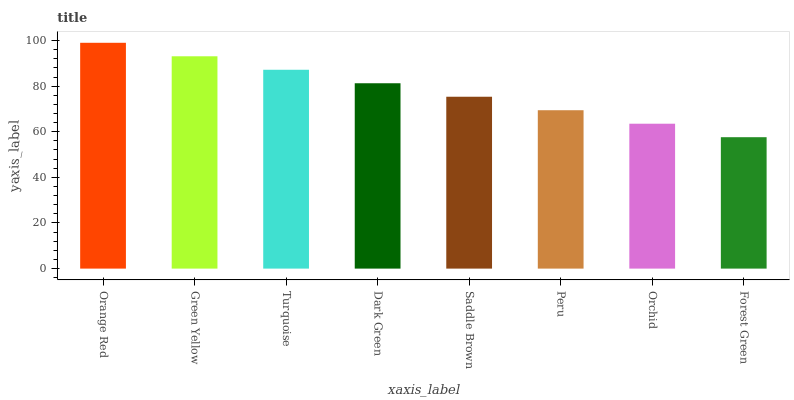Is Forest Green the minimum?
Answer yes or no. Yes. Is Orange Red the maximum?
Answer yes or no. Yes. Is Green Yellow the minimum?
Answer yes or no. No. Is Green Yellow the maximum?
Answer yes or no. No. Is Orange Red greater than Green Yellow?
Answer yes or no. Yes. Is Green Yellow less than Orange Red?
Answer yes or no. Yes. Is Green Yellow greater than Orange Red?
Answer yes or no. No. Is Orange Red less than Green Yellow?
Answer yes or no. No. Is Dark Green the high median?
Answer yes or no. Yes. Is Saddle Brown the low median?
Answer yes or no. Yes. Is Forest Green the high median?
Answer yes or no. No. Is Orange Red the low median?
Answer yes or no. No. 